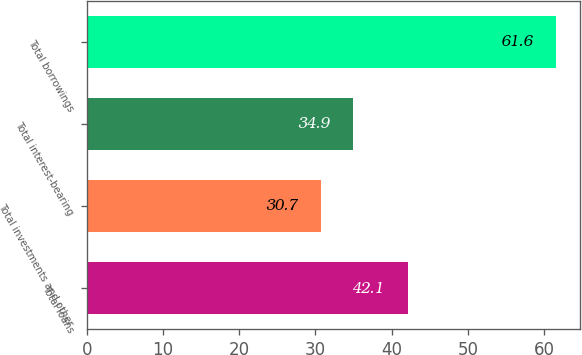Convert chart. <chart><loc_0><loc_0><loc_500><loc_500><bar_chart><fcel>Total loans<fcel>Total investments and other<fcel>Total interest-bearing<fcel>Total borrowings<nl><fcel>42.1<fcel>30.7<fcel>34.9<fcel>61.6<nl></chart> 